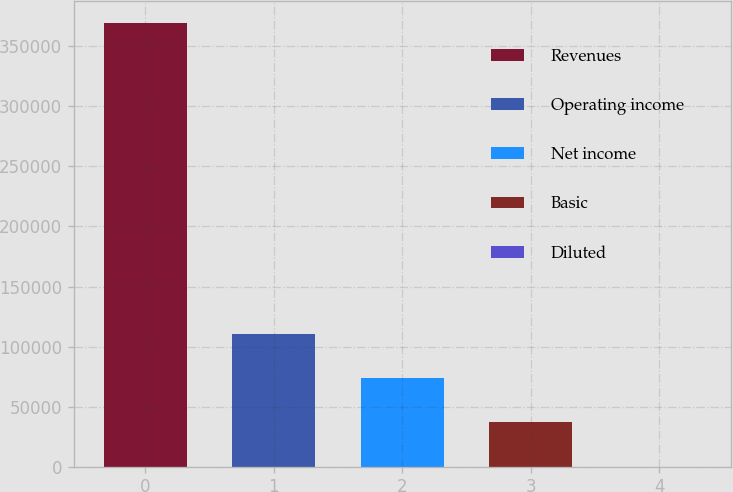Convert chart to OTSL. <chart><loc_0><loc_0><loc_500><loc_500><bar_chart><fcel>Revenues<fcel>Operating income<fcel>Net income<fcel>Basic<fcel>Diluted<nl><fcel>369171<fcel>110752<fcel>73834.5<fcel>36917.4<fcel>0.36<nl></chart> 